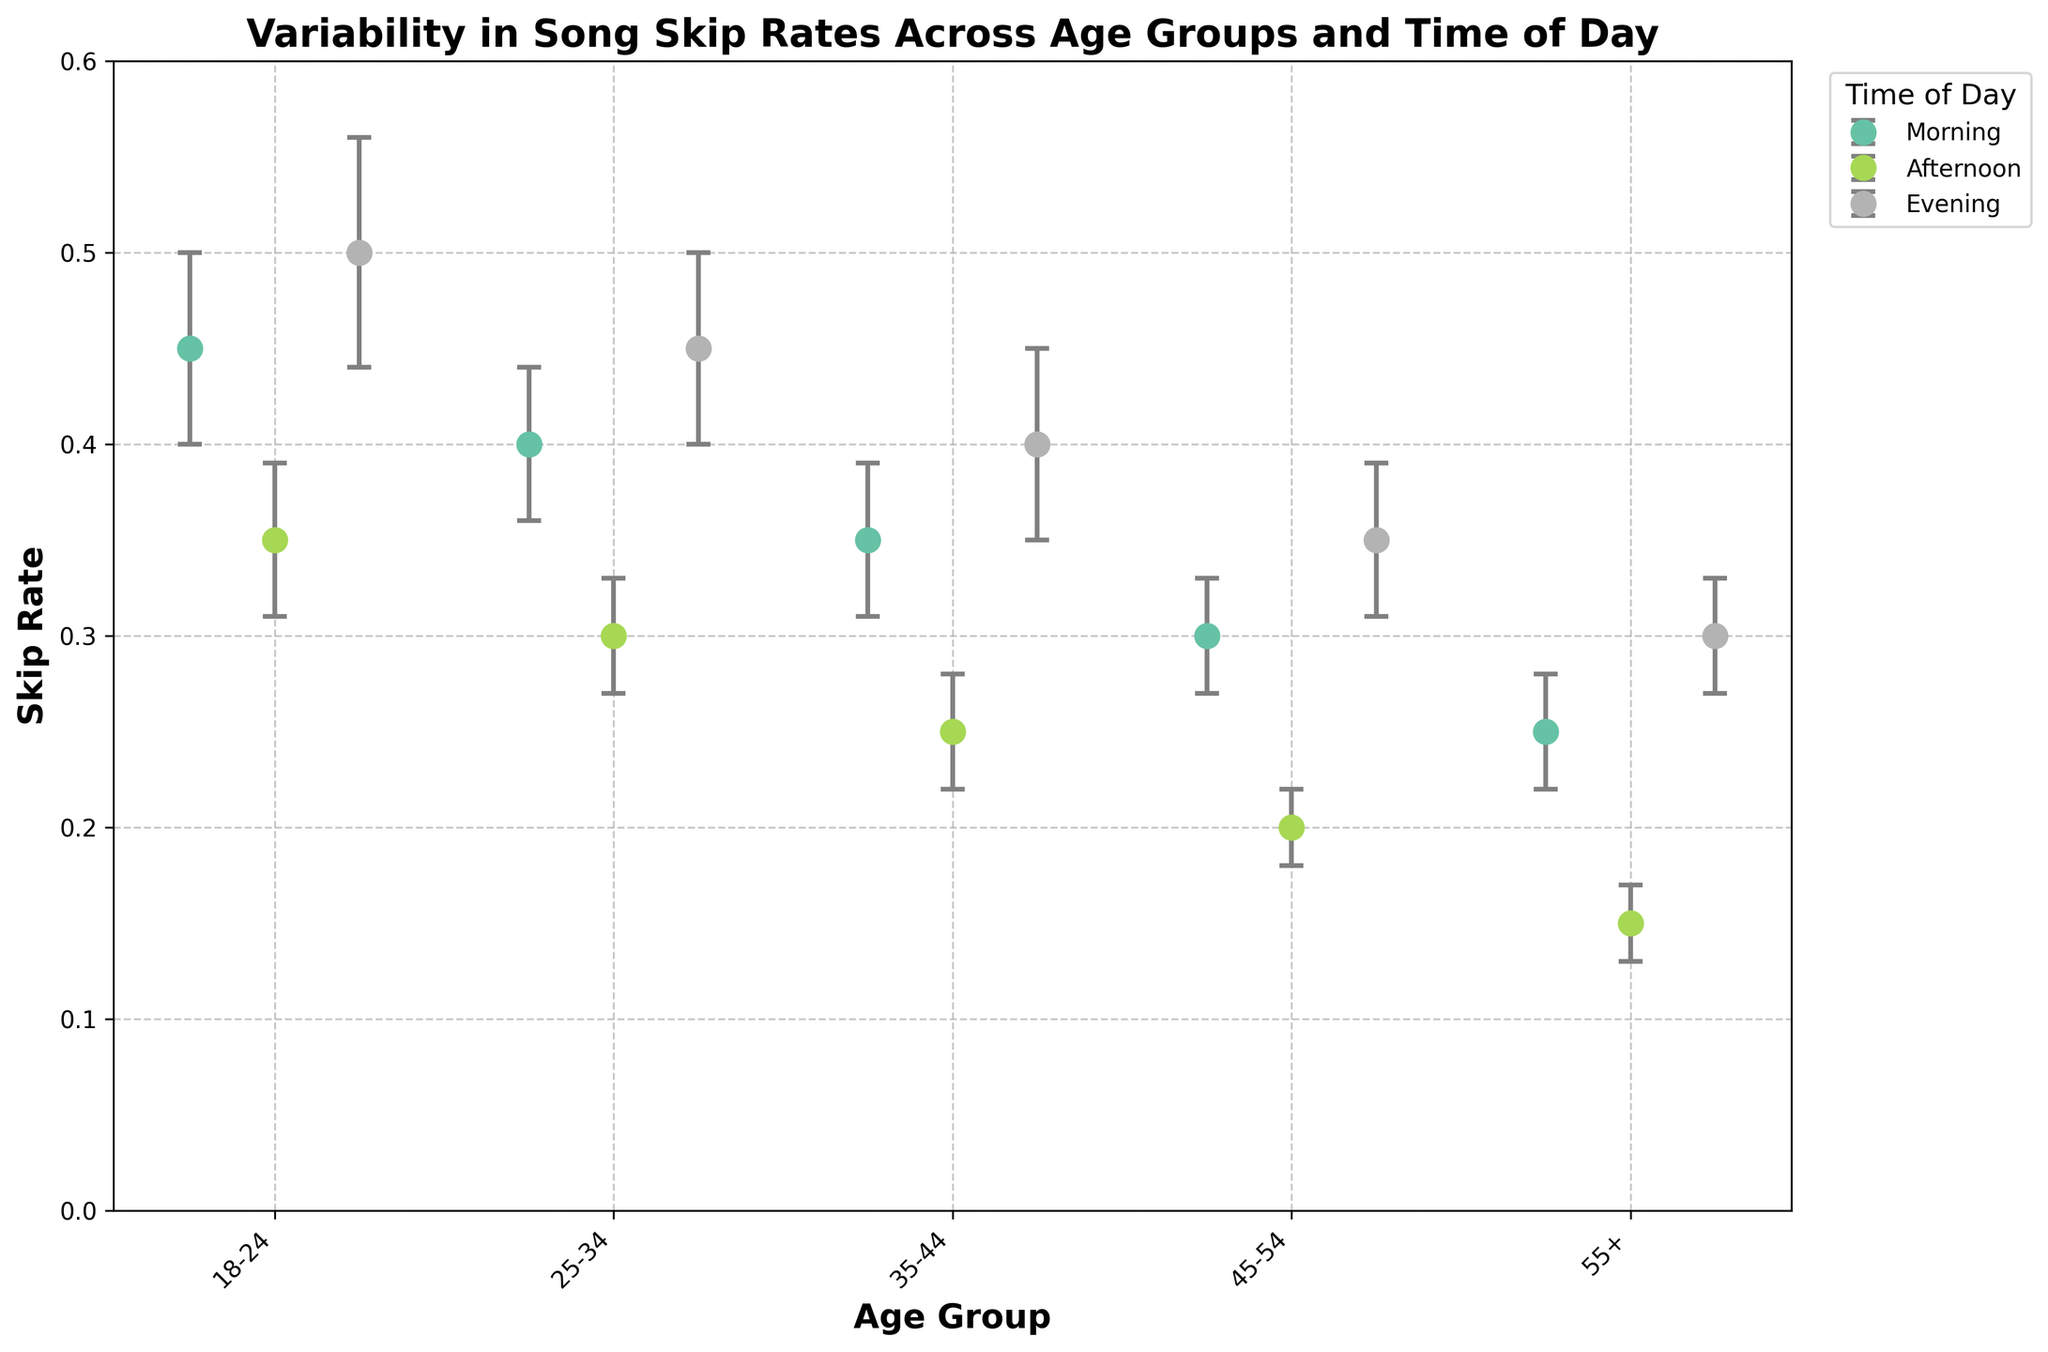What is the skip rate for the 18-24 age group in the morning? Look for the dot corresponding to the 18-24 age group and the morning time of day. Read the skip rate value from the y-axis.
Answer: 0.45 Which age group shows the lowest skip rate in the evening? Identify the dots corresponding to the evening time of day and compare their heights. The lowest height represents the lowest skip rate.
Answer: 55+ What is the difference in skip rate between the 25-34 and 35-44 age groups in the afternoon? Find the dots for the 25-34 and 35-44 age groups in the afternoon. Calculate the difference between their y-values.
Answer: 0.05 What is the trend in skip rates for the 45-54 age group across different times of the day? Observe how the skip rate changes from morning to afternoon to evening for the 45-54 age group.
Answer: Decreasing from morning to afternoon, then increasing in the evening Among all times of the day, which age group exhibits the highest variation in skip rates? Compare the length of all error bars for each age group across different times of the day. The age group with the error bar having the greatest length indicates the highest variation.
Answer: 18-24 Is there any time of day where all age groups have an increasing order of skip rates? Check each time of day and see if the skip rates consistently increase from the youngest to the oldest age group.
Answer: No What is the combined skip rate for the 55+ age group in the morning and afternoon? Add the skip rates for the 55+ age group in the morning and afternoon.
Answer: 0.40 Which time of day has the most consistent skip rates across all age groups? Look for the time of day where the dots have the smallest range (lowest variation) in their y-values. Also, consider the length of error bars.
Answer: Afternoon Compare the morning skip rates for the 18-24 and 25-34 age groups. Are they equal? Find the dots representing the morning skip rates for the 18-24 and 25-34 age groups and compare their y-values.
Answer: No What is the average skip rate for the 35-44 age group across all times of the day? Find the skip rate values for the 35-44 age group at each time of day (morning, afternoon, evening). Sum these values and divide by the number of times of day (3).
Answer: 0.33 